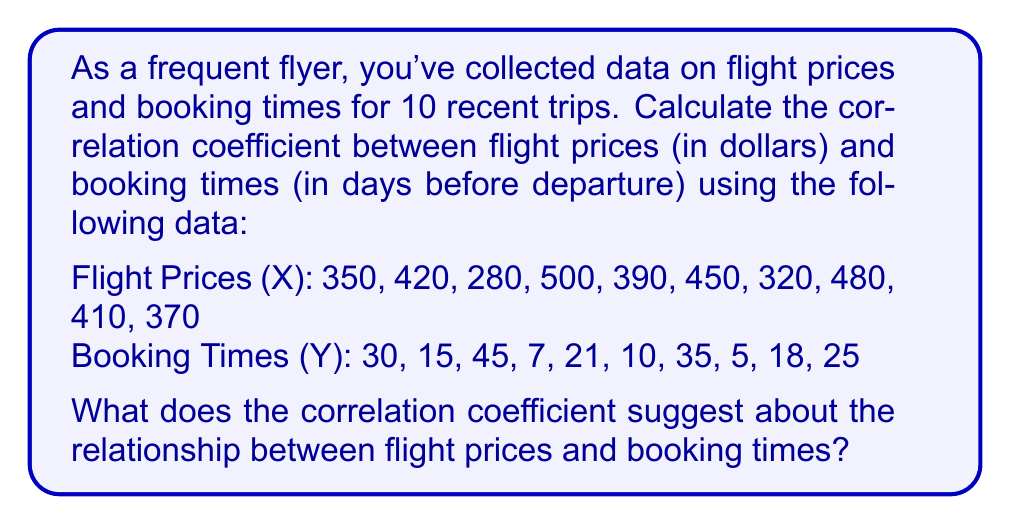Show me your answer to this math problem. To calculate the correlation coefficient, we'll use the Pearson correlation formula:

$$ r = \frac{\sum_{i=1}^{n} (x_i - \bar{x})(y_i - \bar{y})}{\sqrt{\sum_{i=1}^{n} (x_i - \bar{x})^2 \sum_{i=1}^{n} (y_i - \bar{y})^2}} $$

Step 1: Calculate the means
$\bar{x} = \frac{350 + 420 + 280 + 500 + 390 + 450 + 320 + 480 + 410 + 370}{10} = 397$
$\bar{y} = \frac{30 + 15 + 45 + 7 + 21 + 10 + 35 + 5 + 18 + 25}{10} = 21.1$

Step 2: Calculate $(x_i - \bar{x})$, $(y_i - \bar{y})$, $(x_i - \bar{x})^2$, $(y_i - \bar{y})^2$, and $(x_i - \bar{x})(y_i - \bar{y})$ for each pair

Step 3: Sum up the products
$\sum (x_i - \bar{x})(y_i - \bar{y}) = 5,909.9$
$\sum (x_i - \bar{x})^2 = 68,210$
$\sum (y_i - \bar{y})^2 = 1,475.69$

Step 4: Apply the formula
$$ r = \frac{5,909.9}{\sqrt{68,210 \times 1,475.69}} \approx -0.5889 $$

The correlation coefficient is approximately -0.5889. This indicates a moderate negative correlation between flight prices and booking times. As the booking time (days before departure) increases, flight prices tend to decrease, and vice versa.
Answer: $r \approx -0.5889$, indicating a moderate negative correlation 